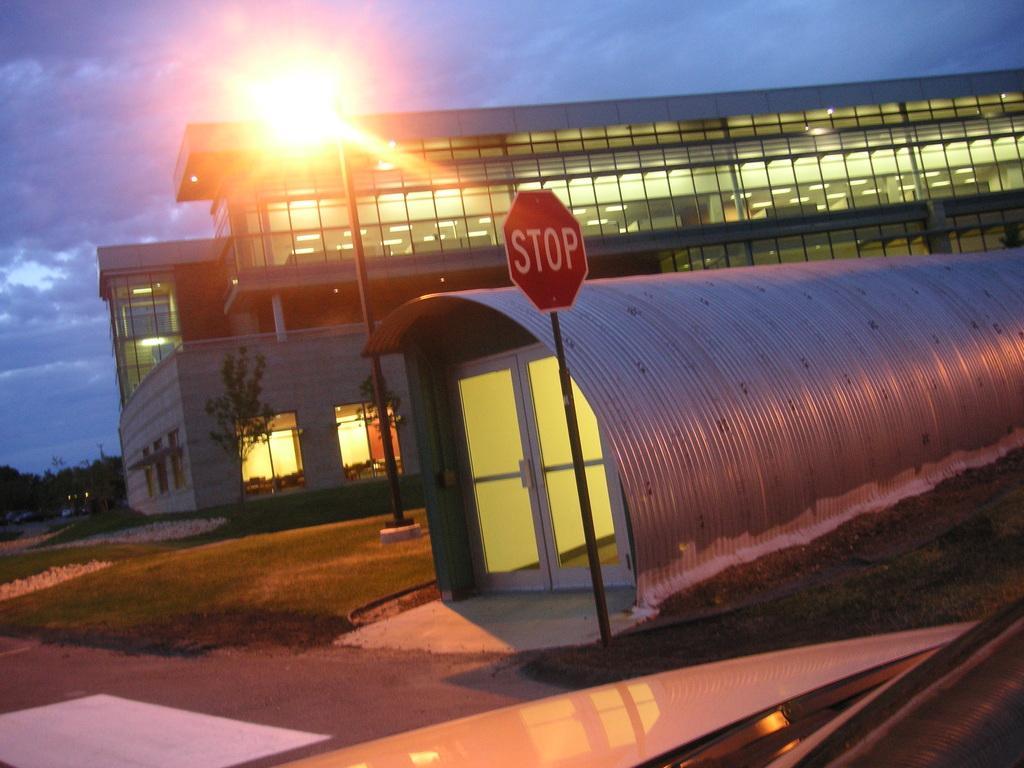<image>
Summarize the visual content of the image. a stop sign that is next to a place with metal on top 